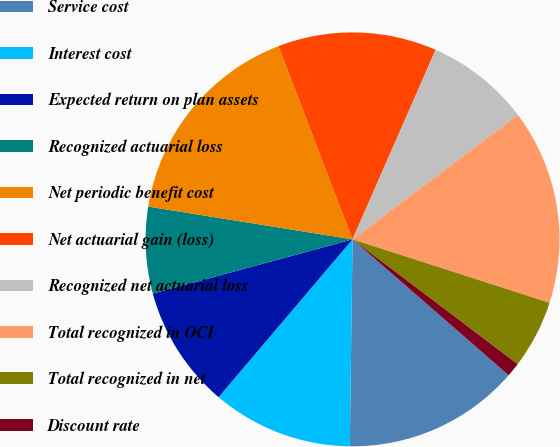<chart> <loc_0><loc_0><loc_500><loc_500><pie_chart><fcel>Service cost<fcel>Interest cost<fcel>Expected return on plan assets<fcel>Recognized actuarial loss<fcel>Net periodic benefit cost<fcel>Net actuarial gain (loss)<fcel>Recognized net actuarial loss<fcel>Total recognized in OCI<fcel>Total recognized in net<fcel>Discount rate<nl><fcel>13.81%<fcel>10.99%<fcel>9.58%<fcel>6.75%<fcel>16.64%<fcel>12.4%<fcel>8.16%<fcel>15.22%<fcel>5.34%<fcel>1.1%<nl></chart> 